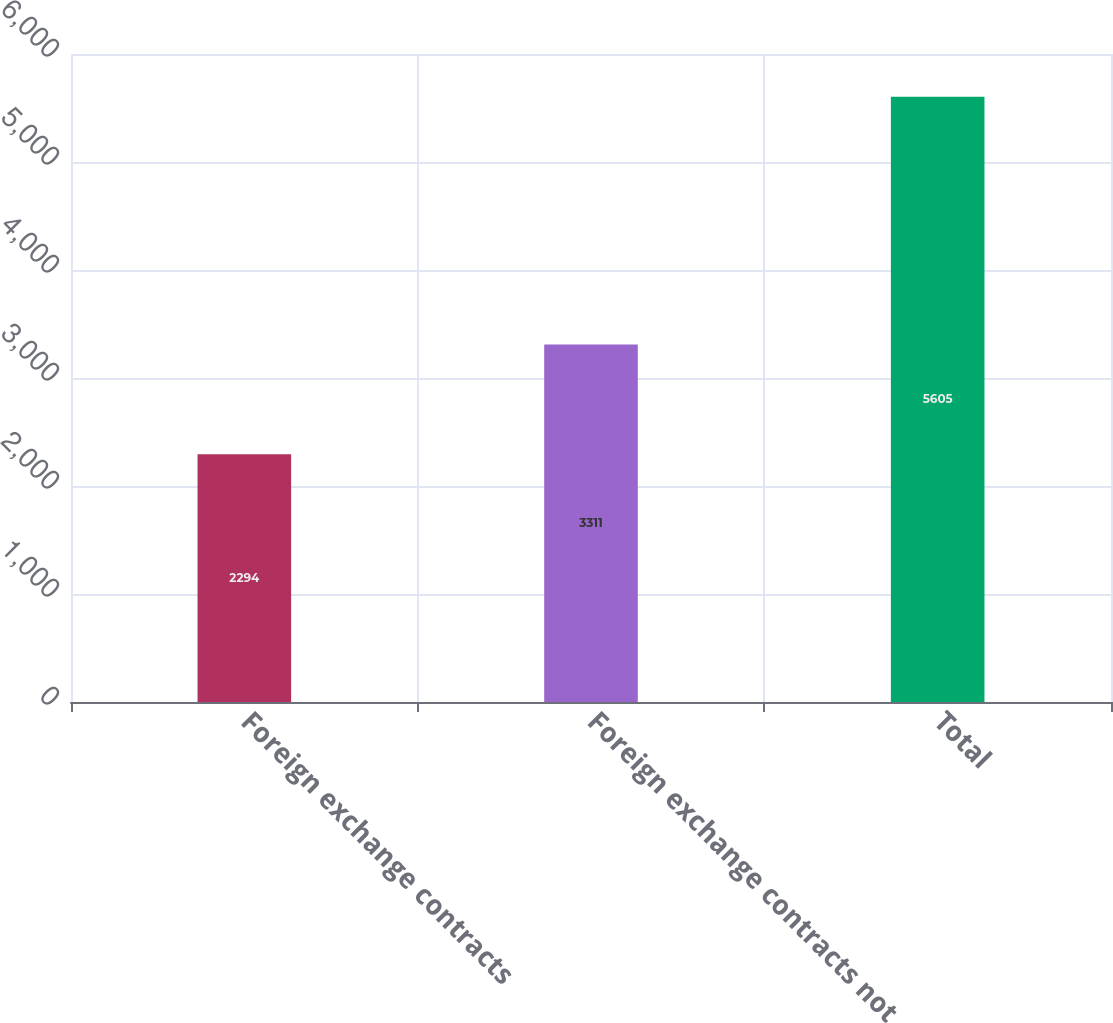Convert chart to OTSL. <chart><loc_0><loc_0><loc_500><loc_500><bar_chart><fcel>Foreign exchange contracts<fcel>Foreign exchange contracts not<fcel>Total<nl><fcel>2294<fcel>3311<fcel>5605<nl></chart> 